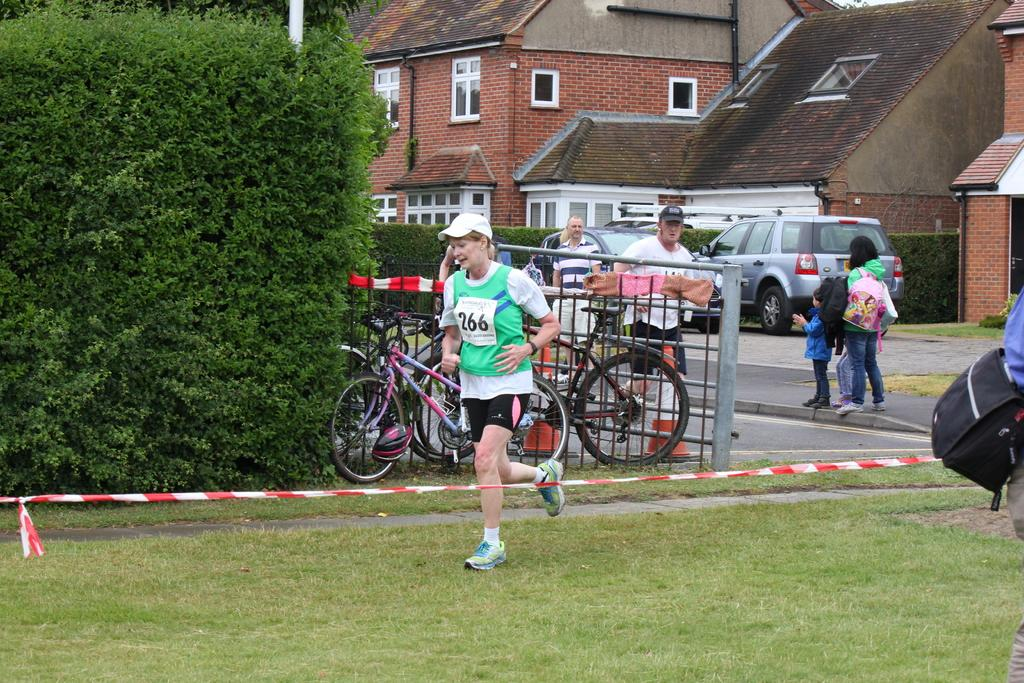What type of structures can be seen in the image? There are buildings in the image. Who or what else is present in the image? There are people and bushes in the image. What mode of transportation can be seen in the image? There are bicycles and other vehicles in the image. What object is present that might be used for displaying signs or advertisements? There is a pole in the image. How does the wave affect the people in the image? There is no wave present in the image; it features buildings, people, bushes, bicycles, other vehicles, and a pole. What type of arithmetic problem can be solved using the support of the pole in the image? The pole in the image is not related to arithmetic problems; it is likely used for displaying signs or advertisements. 